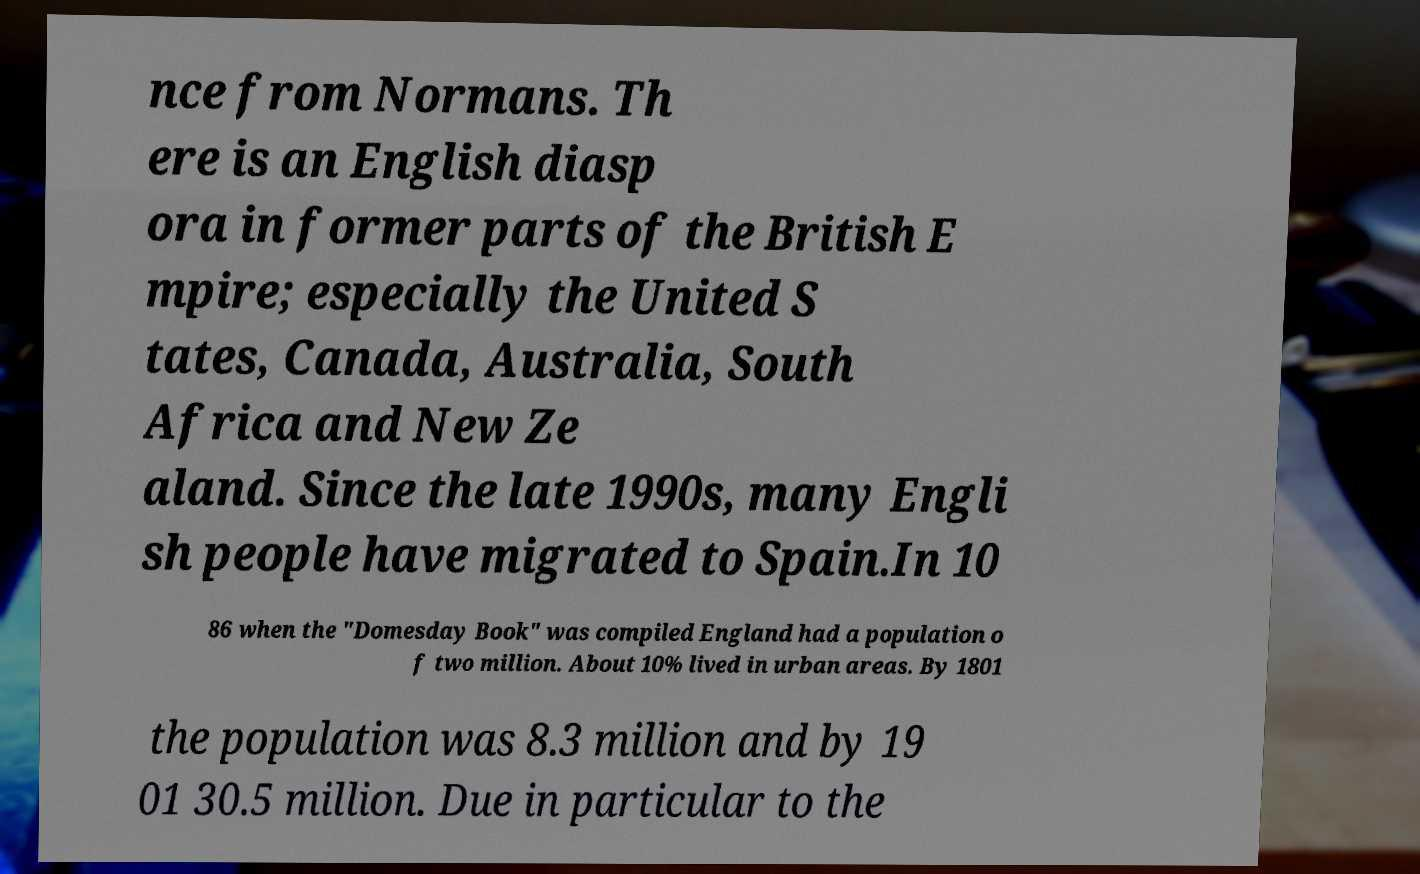Please identify and transcribe the text found in this image. nce from Normans. Th ere is an English diasp ora in former parts of the British E mpire; especially the United S tates, Canada, Australia, South Africa and New Ze aland. Since the late 1990s, many Engli sh people have migrated to Spain.In 10 86 when the "Domesday Book" was compiled England had a population o f two million. About 10% lived in urban areas. By 1801 the population was 8.3 million and by 19 01 30.5 million. Due in particular to the 